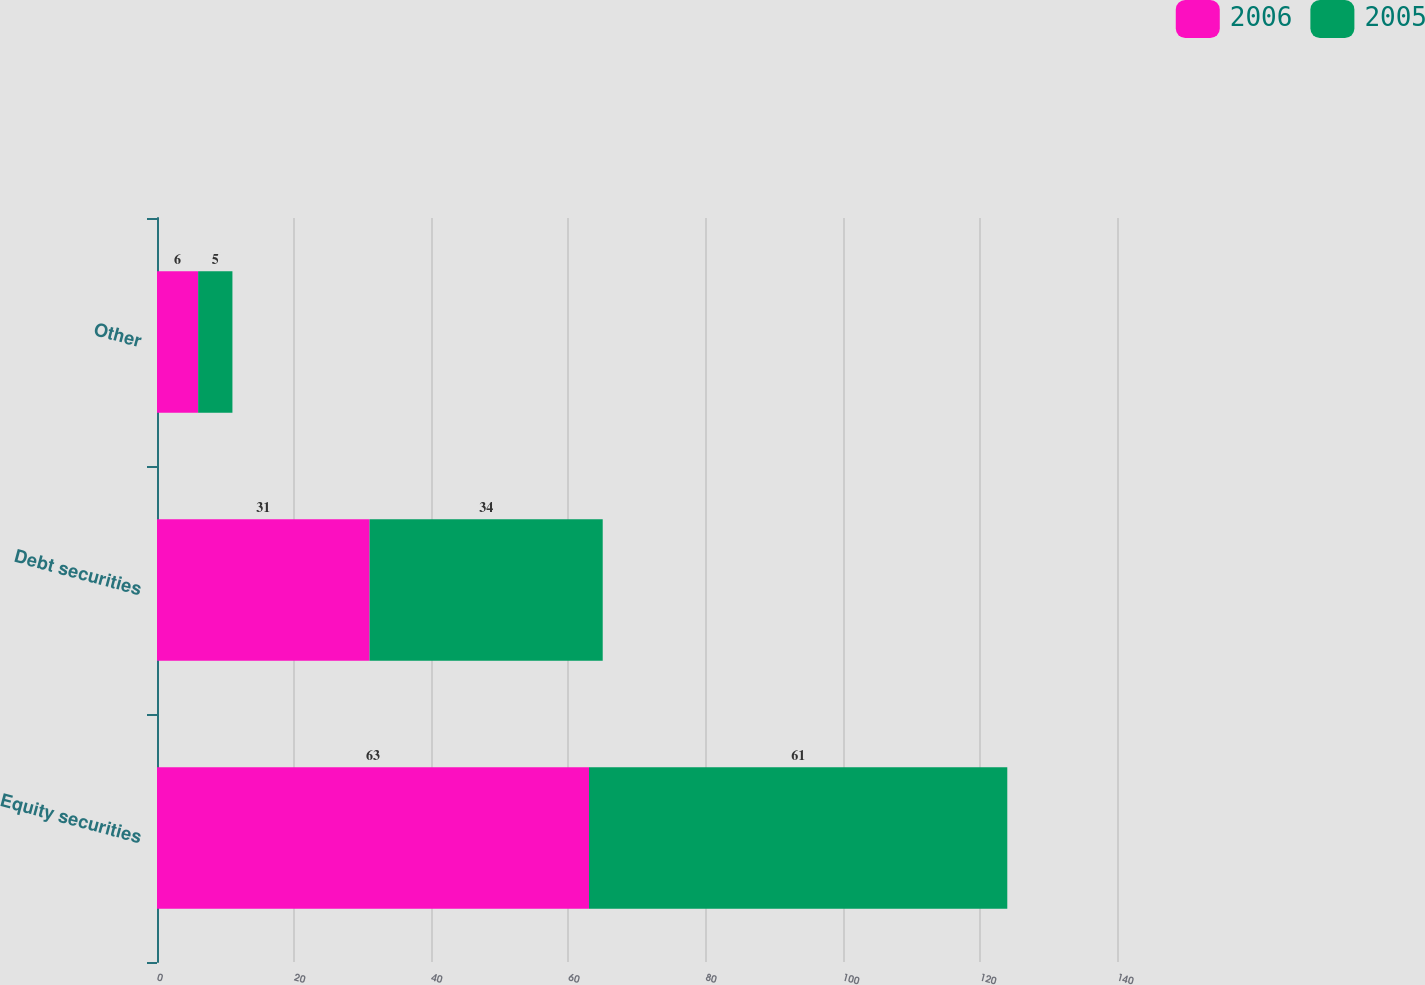<chart> <loc_0><loc_0><loc_500><loc_500><stacked_bar_chart><ecel><fcel>Equity securities<fcel>Debt securities<fcel>Other<nl><fcel>2006<fcel>63<fcel>31<fcel>6<nl><fcel>2005<fcel>61<fcel>34<fcel>5<nl></chart> 